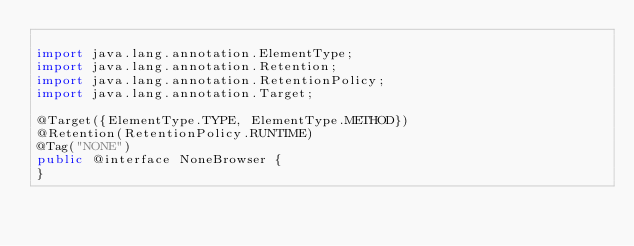<code> <loc_0><loc_0><loc_500><loc_500><_Java_>
import java.lang.annotation.ElementType;
import java.lang.annotation.Retention;
import java.lang.annotation.RetentionPolicy;
import java.lang.annotation.Target;

@Target({ElementType.TYPE, ElementType.METHOD})
@Retention(RetentionPolicy.RUNTIME)
@Tag("NONE")
public @interface NoneBrowser {
}
</code> 